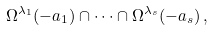<formula> <loc_0><loc_0><loc_500><loc_500>\Omega ^ { \lambda _ { 1 } } ( - a _ { 1 } ) \cap \dots \cap \Omega ^ { \lambda _ { s } } ( - a _ { s } ) \, ,</formula> 